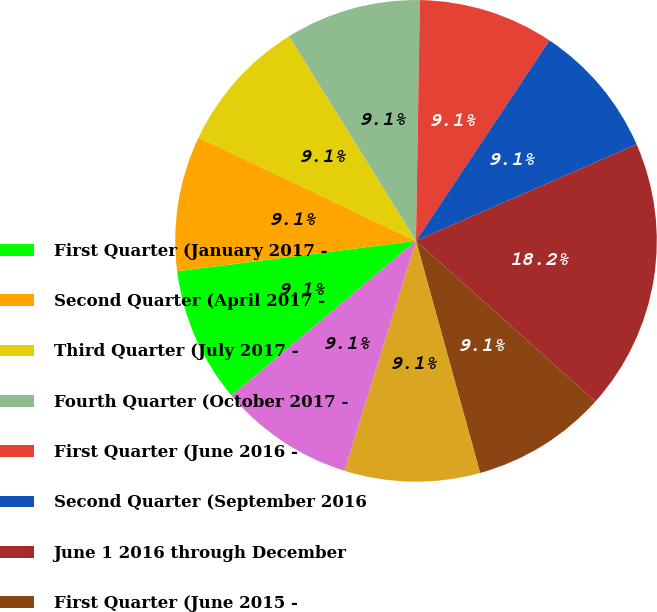Convert chart to OTSL. <chart><loc_0><loc_0><loc_500><loc_500><pie_chart><fcel>First Quarter (January 2017 -<fcel>Second Quarter (April 2017 -<fcel>Third Quarter (July 2017 -<fcel>Fourth Quarter (October 2017 -<fcel>First Quarter (June 2016 -<fcel>Second Quarter (September 2016<fcel>June 1 2016 through December<fcel>First Quarter (June 2015 -<fcel>Second Quarter (September 2015<fcel>Third Quarter (December 2015 -<nl><fcel>9.09%<fcel>9.09%<fcel>9.09%<fcel>9.09%<fcel>9.09%<fcel>9.09%<fcel>18.18%<fcel>9.09%<fcel>9.09%<fcel>9.09%<nl></chart> 